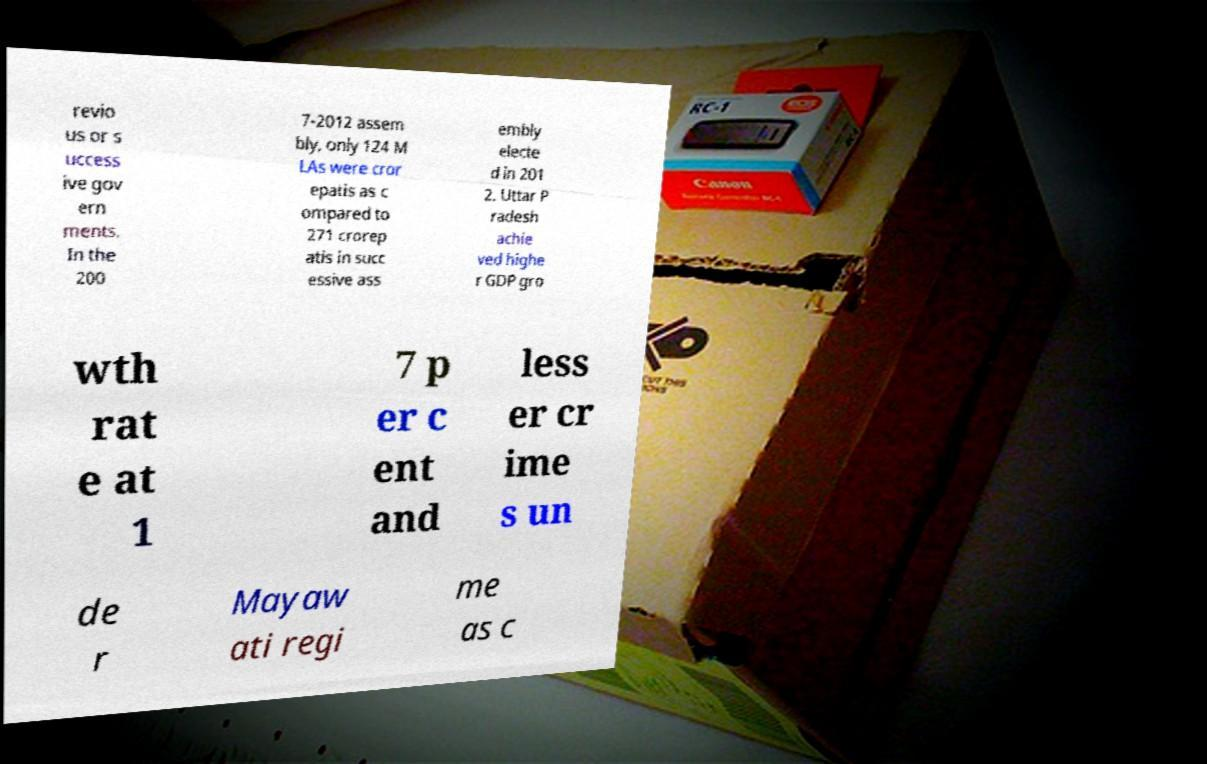Please identify and transcribe the text found in this image. revio us or s uccess ive gov ern ments. In the 200 7-2012 assem bly, only 124 M LAs were cror epatis as c ompared to 271 crorep atis in succ essive ass embly electe d in 201 2. Uttar P radesh achie ved highe r GDP gro wth rat e at 1 7 p er c ent and less er cr ime s un de r Mayaw ati regi me as c 